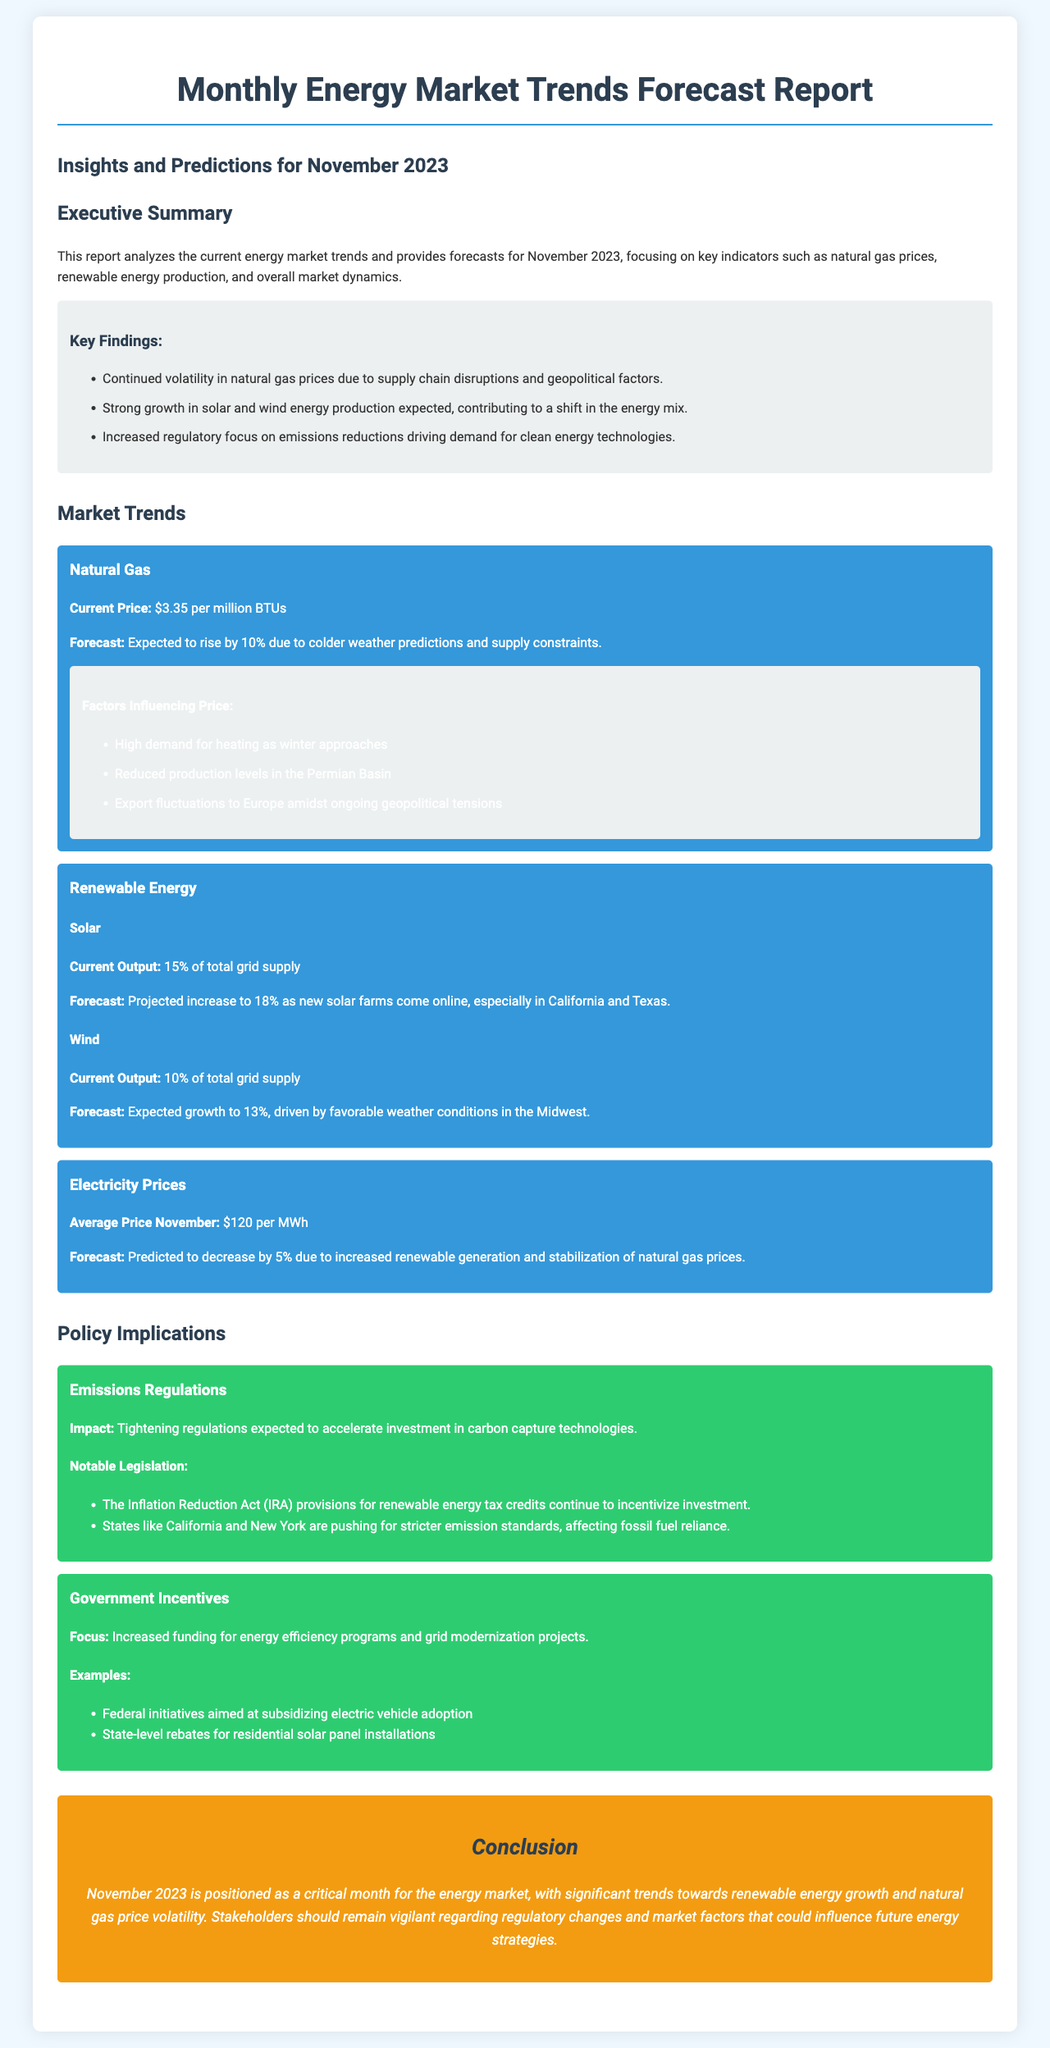what is the current price of natural gas? The document lists the current price of natural gas as $3.35 per million BTUs.
Answer: $3.35 per million BTUs what is the forecasted increase in solar energy output? Solar energy output is projected to increase from 15% to 18% of total grid supply.
Answer: 18% what are the factors influencing natural gas prices? Three factors are mentioned: high heating demand, reduced production levels, and export fluctuations.
Answer: High demand for heating, reduced production levels, export fluctuations what is the average electricity price predicted for November? The document states the average price of electricity for November is $120 per MWh.
Answer: $120 per MWh what is the impact of the tightening emissions regulations? The report indicates that tightening regulations are expected to accelerate investment in carbon capture technologies.
Answer: Accelerate investment in carbon capture technologies what is the current output percentage of wind energy? The current output of wind energy is stated to be 10% of total grid supply.
Answer: 10% which act is mentioned as incentivizing renewable energy investments? The document refers to the Inflation Reduction Act as a legislative measure incentivizing investments.
Answer: The Inflation Reduction Act (IRA) what is the expected growth in wind energy output? Wind energy output is expected to grow to 13% due to favorable weather conditions.
Answer: 13% what is the significance of November 2023 for the energy market? The conclusion notes that November 2023 is positioned as critical for renewable energy growth and natural gas volatility.
Answer: Critical month for the energy market 